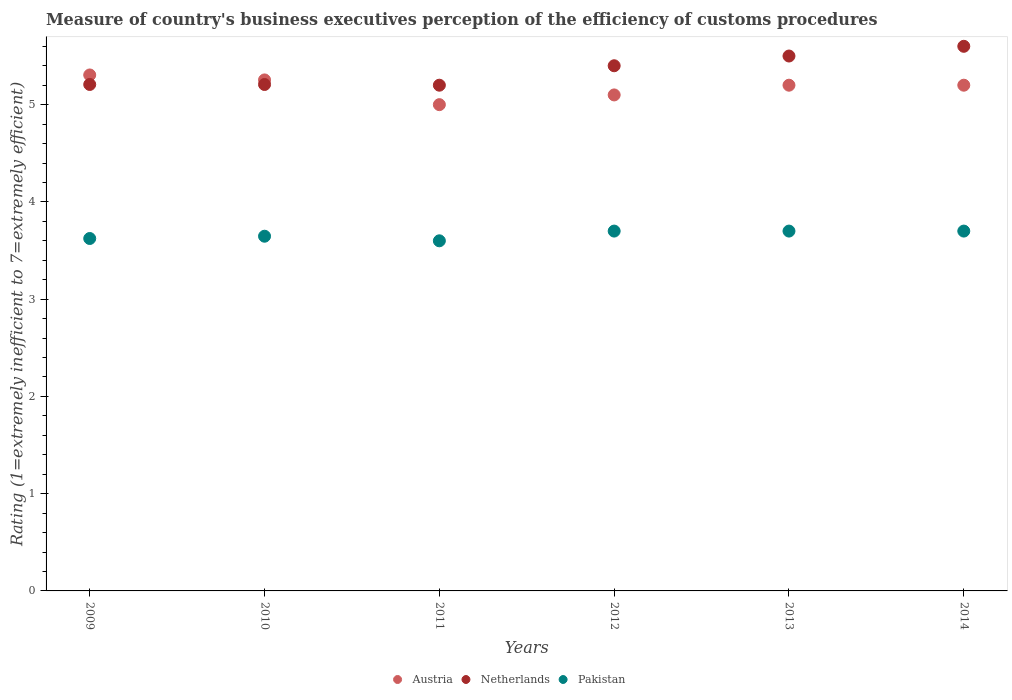What is the rating of the efficiency of customs procedure in Pakistan in 2014?
Ensure brevity in your answer.  3.7. Across all years, what is the maximum rating of the efficiency of customs procedure in Pakistan?
Offer a very short reply. 3.7. What is the total rating of the efficiency of customs procedure in Austria in the graph?
Your answer should be compact. 31.06. What is the difference between the rating of the efficiency of customs procedure in Netherlands in 2010 and that in 2014?
Your answer should be very brief. -0.39. What is the difference between the rating of the efficiency of customs procedure in Austria in 2011 and the rating of the efficiency of customs procedure in Pakistan in 2010?
Offer a very short reply. 1.35. What is the average rating of the efficiency of customs procedure in Netherlands per year?
Offer a terse response. 5.35. In how many years, is the rating of the efficiency of customs procedure in Pakistan greater than 0.8?
Provide a succinct answer. 6. What is the ratio of the rating of the efficiency of customs procedure in Austria in 2009 to that in 2012?
Provide a short and direct response. 1.04. Is the rating of the efficiency of customs procedure in Netherlands in 2010 less than that in 2012?
Offer a terse response. Yes. Is the difference between the rating of the efficiency of customs procedure in Pakistan in 2010 and 2012 greater than the difference between the rating of the efficiency of customs procedure in Austria in 2010 and 2012?
Offer a very short reply. No. What is the difference between the highest and the lowest rating of the efficiency of customs procedure in Netherlands?
Provide a short and direct response. 0.4. Is the sum of the rating of the efficiency of customs procedure in Netherlands in 2009 and 2014 greater than the maximum rating of the efficiency of customs procedure in Austria across all years?
Make the answer very short. Yes. Is it the case that in every year, the sum of the rating of the efficiency of customs procedure in Austria and rating of the efficiency of customs procedure in Pakistan  is greater than the rating of the efficiency of customs procedure in Netherlands?
Ensure brevity in your answer.  Yes. Does the rating of the efficiency of customs procedure in Pakistan monotonically increase over the years?
Give a very brief answer. No. Is the rating of the efficiency of customs procedure in Austria strictly greater than the rating of the efficiency of customs procedure in Pakistan over the years?
Offer a very short reply. Yes. How many dotlines are there?
Your answer should be compact. 3. How many years are there in the graph?
Ensure brevity in your answer.  6. How many legend labels are there?
Give a very brief answer. 3. What is the title of the graph?
Keep it short and to the point. Measure of country's business executives perception of the efficiency of customs procedures. What is the label or title of the X-axis?
Make the answer very short. Years. What is the label or title of the Y-axis?
Your answer should be very brief. Rating (1=extremely inefficient to 7=extremely efficient). What is the Rating (1=extremely inefficient to 7=extremely efficient) of Austria in 2009?
Keep it short and to the point. 5.31. What is the Rating (1=extremely inefficient to 7=extremely efficient) of Netherlands in 2009?
Offer a terse response. 5.21. What is the Rating (1=extremely inefficient to 7=extremely efficient) of Pakistan in 2009?
Your answer should be very brief. 3.62. What is the Rating (1=extremely inefficient to 7=extremely efficient) in Austria in 2010?
Your response must be concise. 5.25. What is the Rating (1=extremely inefficient to 7=extremely efficient) of Netherlands in 2010?
Keep it short and to the point. 5.21. What is the Rating (1=extremely inefficient to 7=extremely efficient) of Pakistan in 2010?
Your answer should be compact. 3.65. What is the Rating (1=extremely inefficient to 7=extremely efficient) of Netherlands in 2011?
Make the answer very short. 5.2. What is the Rating (1=extremely inefficient to 7=extremely efficient) in Pakistan in 2011?
Offer a terse response. 3.6. What is the Rating (1=extremely inefficient to 7=extremely efficient) in Netherlands in 2012?
Provide a short and direct response. 5.4. What is the Rating (1=extremely inefficient to 7=extremely efficient) in Pakistan in 2013?
Your response must be concise. 3.7. What is the Rating (1=extremely inefficient to 7=extremely efficient) in Austria in 2014?
Offer a terse response. 5.2. Across all years, what is the maximum Rating (1=extremely inefficient to 7=extremely efficient) in Austria?
Provide a succinct answer. 5.31. Across all years, what is the minimum Rating (1=extremely inefficient to 7=extremely efficient) of Pakistan?
Your answer should be very brief. 3.6. What is the total Rating (1=extremely inefficient to 7=extremely efficient) of Austria in the graph?
Offer a very short reply. 31.06. What is the total Rating (1=extremely inefficient to 7=extremely efficient) in Netherlands in the graph?
Offer a very short reply. 32.11. What is the total Rating (1=extremely inefficient to 7=extremely efficient) of Pakistan in the graph?
Provide a short and direct response. 21.97. What is the difference between the Rating (1=extremely inefficient to 7=extremely efficient) of Austria in 2009 and that in 2010?
Your answer should be compact. 0.05. What is the difference between the Rating (1=extremely inefficient to 7=extremely efficient) in Pakistan in 2009 and that in 2010?
Ensure brevity in your answer.  -0.02. What is the difference between the Rating (1=extremely inefficient to 7=extremely efficient) of Austria in 2009 and that in 2011?
Provide a succinct answer. 0.31. What is the difference between the Rating (1=extremely inefficient to 7=extremely efficient) in Netherlands in 2009 and that in 2011?
Provide a short and direct response. 0.01. What is the difference between the Rating (1=extremely inefficient to 7=extremely efficient) of Pakistan in 2009 and that in 2011?
Make the answer very short. 0.02. What is the difference between the Rating (1=extremely inefficient to 7=extremely efficient) in Austria in 2009 and that in 2012?
Offer a terse response. 0.21. What is the difference between the Rating (1=extremely inefficient to 7=extremely efficient) of Netherlands in 2009 and that in 2012?
Provide a short and direct response. -0.19. What is the difference between the Rating (1=extremely inefficient to 7=extremely efficient) of Pakistan in 2009 and that in 2012?
Provide a short and direct response. -0.08. What is the difference between the Rating (1=extremely inefficient to 7=extremely efficient) of Austria in 2009 and that in 2013?
Your answer should be compact. 0.11. What is the difference between the Rating (1=extremely inefficient to 7=extremely efficient) in Netherlands in 2009 and that in 2013?
Ensure brevity in your answer.  -0.29. What is the difference between the Rating (1=extremely inefficient to 7=extremely efficient) in Pakistan in 2009 and that in 2013?
Ensure brevity in your answer.  -0.08. What is the difference between the Rating (1=extremely inefficient to 7=extremely efficient) in Austria in 2009 and that in 2014?
Your answer should be very brief. 0.11. What is the difference between the Rating (1=extremely inefficient to 7=extremely efficient) of Netherlands in 2009 and that in 2014?
Offer a terse response. -0.39. What is the difference between the Rating (1=extremely inefficient to 7=extremely efficient) in Pakistan in 2009 and that in 2014?
Provide a succinct answer. -0.08. What is the difference between the Rating (1=extremely inefficient to 7=extremely efficient) in Austria in 2010 and that in 2011?
Your answer should be very brief. 0.25. What is the difference between the Rating (1=extremely inefficient to 7=extremely efficient) of Netherlands in 2010 and that in 2011?
Offer a very short reply. 0.01. What is the difference between the Rating (1=extremely inefficient to 7=extremely efficient) in Pakistan in 2010 and that in 2011?
Your answer should be compact. 0.05. What is the difference between the Rating (1=extremely inefficient to 7=extremely efficient) in Austria in 2010 and that in 2012?
Offer a very short reply. 0.15. What is the difference between the Rating (1=extremely inefficient to 7=extremely efficient) in Netherlands in 2010 and that in 2012?
Ensure brevity in your answer.  -0.19. What is the difference between the Rating (1=extremely inefficient to 7=extremely efficient) of Pakistan in 2010 and that in 2012?
Offer a terse response. -0.05. What is the difference between the Rating (1=extremely inefficient to 7=extremely efficient) of Austria in 2010 and that in 2013?
Your response must be concise. 0.05. What is the difference between the Rating (1=extremely inefficient to 7=extremely efficient) of Netherlands in 2010 and that in 2013?
Give a very brief answer. -0.29. What is the difference between the Rating (1=extremely inefficient to 7=extremely efficient) of Pakistan in 2010 and that in 2013?
Your answer should be compact. -0.05. What is the difference between the Rating (1=extremely inefficient to 7=extremely efficient) in Austria in 2010 and that in 2014?
Keep it short and to the point. 0.05. What is the difference between the Rating (1=extremely inefficient to 7=extremely efficient) in Netherlands in 2010 and that in 2014?
Ensure brevity in your answer.  -0.39. What is the difference between the Rating (1=extremely inefficient to 7=extremely efficient) of Pakistan in 2010 and that in 2014?
Keep it short and to the point. -0.05. What is the difference between the Rating (1=extremely inefficient to 7=extremely efficient) in Pakistan in 2011 and that in 2012?
Make the answer very short. -0.1. What is the difference between the Rating (1=extremely inefficient to 7=extremely efficient) of Austria in 2011 and that in 2013?
Make the answer very short. -0.2. What is the difference between the Rating (1=extremely inefficient to 7=extremely efficient) of Pakistan in 2011 and that in 2013?
Offer a terse response. -0.1. What is the difference between the Rating (1=extremely inefficient to 7=extremely efficient) in Pakistan in 2011 and that in 2014?
Your response must be concise. -0.1. What is the difference between the Rating (1=extremely inefficient to 7=extremely efficient) in Austria in 2012 and that in 2013?
Your response must be concise. -0.1. What is the difference between the Rating (1=extremely inefficient to 7=extremely efficient) of Netherlands in 2012 and that in 2013?
Provide a succinct answer. -0.1. What is the difference between the Rating (1=extremely inefficient to 7=extremely efficient) of Pakistan in 2012 and that in 2014?
Your answer should be compact. 0. What is the difference between the Rating (1=extremely inefficient to 7=extremely efficient) of Austria in 2013 and that in 2014?
Your response must be concise. 0. What is the difference between the Rating (1=extremely inefficient to 7=extremely efficient) in Pakistan in 2013 and that in 2014?
Keep it short and to the point. 0. What is the difference between the Rating (1=extremely inefficient to 7=extremely efficient) in Austria in 2009 and the Rating (1=extremely inefficient to 7=extremely efficient) in Netherlands in 2010?
Offer a very short reply. 0.1. What is the difference between the Rating (1=extremely inefficient to 7=extremely efficient) in Austria in 2009 and the Rating (1=extremely inefficient to 7=extremely efficient) in Pakistan in 2010?
Your response must be concise. 1.66. What is the difference between the Rating (1=extremely inefficient to 7=extremely efficient) in Netherlands in 2009 and the Rating (1=extremely inefficient to 7=extremely efficient) in Pakistan in 2010?
Give a very brief answer. 1.56. What is the difference between the Rating (1=extremely inefficient to 7=extremely efficient) of Austria in 2009 and the Rating (1=extremely inefficient to 7=extremely efficient) of Netherlands in 2011?
Ensure brevity in your answer.  0.11. What is the difference between the Rating (1=extremely inefficient to 7=extremely efficient) in Austria in 2009 and the Rating (1=extremely inefficient to 7=extremely efficient) in Pakistan in 2011?
Make the answer very short. 1.71. What is the difference between the Rating (1=extremely inefficient to 7=extremely efficient) in Netherlands in 2009 and the Rating (1=extremely inefficient to 7=extremely efficient) in Pakistan in 2011?
Provide a succinct answer. 1.61. What is the difference between the Rating (1=extremely inefficient to 7=extremely efficient) of Austria in 2009 and the Rating (1=extremely inefficient to 7=extremely efficient) of Netherlands in 2012?
Make the answer very short. -0.09. What is the difference between the Rating (1=extremely inefficient to 7=extremely efficient) of Austria in 2009 and the Rating (1=extremely inefficient to 7=extremely efficient) of Pakistan in 2012?
Your answer should be compact. 1.61. What is the difference between the Rating (1=extremely inefficient to 7=extremely efficient) of Netherlands in 2009 and the Rating (1=extremely inefficient to 7=extremely efficient) of Pakistan in 2012?
Your answer should be very brief. 1.51. What is the difference between the Rating (1=extremely inefficient to 7=extremely efficient) in Austria in 2009 and the Rating (1=extremely inefficient to 7=extremely efficient) in Netherlands in 2013?
Your answer should be compact. -0.19. What is the difference between the Rating (1=extremely inefficient to 7=extremely efficient) of Austria in 2009 and the Rating (1=extremely inefficient to 7=extremely efficient) of Pakistan in 2013?
Provide a short and direct response. 1.61. What is the difference between the Rating (1=extremely inefficient to 7=extremely efficient) of Netherlands in 2009 and the Rating (1=extremely inefficient to 7=extremely efficient) of Pakistan in 2013?
Give a very brief answer. 1.51. What is the difference between the Rating (1=extremely inefficient to 7=extremely efficient) in Austria in 2009 and the Rating (1=extremely inefficient to 7=extremely efficient) in Netherlands in 2014?
Provide a succinct answer. -0.29. What is the difference between the Rating (1=extremely inefficient to 7=extremely efficient) of Austria in 2009 and the Rating (1=extremely inefficient to 7=extremely efficient) of Pakistan in 2014?
Provide a succinct answer. 1.61. What is the difference between the Rating (1=extremely inefficient to 7=extremely efficient) of Netherlands in 2009 and the Rating (1=extremely inefficient to 7=extremely efficient) of Pakistan in 2014?
Make the answer very short. 1.51. What is the difference between the Rating (1=extremely inefficient to 7=extremely efficient) in Austria in 2010 and the Rating (1=extremely inefficient to 7=extremely efficient) in Netherlands in 2011?
Keep it short and to the point. 0.05. What is the difference between the Rating (1=extremely inefficient to 7=extremely efficient) in Austria in 2010 and the Rating (1=extremely inefficient to 7=extremely efficient) in Pakistan in 2011?
Offer a very short reply. 1.65. What is the difference between the Rating (1=extremely inefficient to 7=extremely efficient) in Netherlands in 2010 and the Rating (1=extremely inefficient to 7=extremely efficient) in Pakistan in 2011?
Give a very brief answer. 1.61. What is the difference between the Rating (1=extremely inefficient to 7=extremely efficient) of Austria in 2010 and the Rating (1=extremely inefficient to 7=extremely efficient) of Netherlands in 2012?
Your answer should be compact. -0.15. What is the difference between the Rating (1=extremely inefficient to 7=extremely efficient) of Austria in 2010 and the Rating (1=extremely inefficient to 7=extremely efficient) of Pakistan in 2012?
Offer a very short reply. 1.55. What is the difference between the Rating (1=extremely inefficient to 7=extremely efficient) in Netherlands in 2010 and the Rating (1=extremely inefficient to 7=extremely efficient) in Pakistan in 2012?
Your response must be concise. 1.51. What is the difference between the Rating (1=extremely inefficient to 7=extremely efficient) in Austria in 2010 and the Rating (1=extremely inefficient to 7=extremely efficient) in Netherlands in 2013?
Provide a short and direct response. -0.25. What is the difference between the Rating (1=extremely inefficient to 7=extremely efficient) of Austria in 2010 and the Rating (1=extremely inefficient to 7=extremely efficient) of Pakistan in 2013?
Provide a succinct answer. 1.55. What is the difference between the Rating (1=extremely inefficient to 7=extremely efficient) in Netherlands in 2010 and the Rating (1=extremely inefficient to 7=extremely efficient) in Pakistan in 2013?
Give a very brief answer. 1.51. What is the difference between the Rating (1=extremely inefficient to 7=extremely efficient) of Austria in 2010 and the Rating (1=extremely inefficient to 7=extremely efficient) of Netherlands in 2014?
Offer a very short reply. -0.35. What is the difference between the Rating (1=extremely inefficient to 7=extremely efficient) in Austria in 2010 and the Rating (1=extremely inefficient to 7=extremely efficient) in Pakistan in 2014?
Offer a very short reply. 1.55. What is the difference between the Rating (1=extremely inefficient to 7=extremely efficient) of Netherlands in 2010 and the Rating (1=extremely inefficient to 7=extremely efficient) of Pakistan in 2014?
Make the answer very short. 1.51. What is the difference between the Rating (1=extremely inefficient to 7=extremely efficient) of Austria in 2011 and the Rating (1=extremely inefficient to 7=extremely efficient) of Pakistan in 2012?
Your answer should be very brief. 1.3. What is the difference between the Rating (1=extremely inefficient to 7=extremely efficient) in Netherlands in 2011 and the Rating (1=extremely inefficient to 7=extremely efficient) in Pakistan in 2012?
Your answer should be very brief. 1.5. What is the difference between the Rating (1=extremely inefficient to 7=extremely efficient) of Austria in 2011 and the Rating (1=extremely inefficient to 7=extremely efficient) of Netherlands in 2013?
Make the answer very short. -0.5. What is the difference between the Rating (1=extremely inefficient to 7=extremely efficient) of Austria in 2011 and the Rating (1=extremely inefficient to 7=extremely efficient) of Pakistan in 2014?
Offer a terse response. 1.3. What is the difference between the Rating (1=extremely inefficient to 7=extremely efficient) of Netherlands in 2011 and the Rating (1=extremely inefficient to 7=extremely efficient) of Pakistan in 2014?
Give a very brief answer. 1.5. What is the difference between the Rating (1=extremely inefficient to 7=extremely efficient) of Austria in 2012 and the Rating (1=extremely inefficient to 7=extremely efficient) of Netherlands in 2013?
Ensure brevity in your answer.  -0.4. What is the difference between the Rating (1=extremely inefficient to 7=extremely efficient) of Austria in 2012 and the Rating (1=extremely inefficient to 7=extremely efficient) of Pakistan in 2013?
Offer a very short reply. 1.4. What is the difference between the Rating (1=extremely inefficient to 7=extremely efficient) in Austria in 2012 and the Rating (1=extremely inefficient to 7=extremely efficient) in Netherlands in 2014?
Offer a very short reply. -0.5. What is the difference between the Rating (1=extremely inefficient to 7=extremely efficient) in Austria in 2012 and the Rating (1=extremely inefficient to 7=extremely efficient) in Pakistan in 2014?
Keep it short and to the point. 1.4. What is the average Rating (1=extremely inefficient to 7=extremely efficient) in Austria per year?
Make the answer very short. 5.18. What is the average Rating (1=extremely inefficient to 7=extremely efficient) in Netherlands per year?
Offer a terse response. 5.35. What is the average Rating (1=extremely inefficient to 7=extremely efficient) of Pakistan per year?
Give a very brief answer. 3.66. In the year 2009, what is the difference between the Rating (1=extremely inefficient to 7=extremely efficient) of Austria and Rating (1=extremely inefficient to 7=extremely efficient) of Netherlands?
Offer a very short reply. 0.1. In the year 2009, what is the difference between the Rating (1=extremely inefficient to 7=extremely efficient) in Austria and Rating (1=extremely inefficient to 7=extremely efficient) in Pakistan?
Offer a very short reply. 1.68. In the year 2009, what is the difference between the Rating (1=extremely inefficient to 7=extremely efficient) in Netherlands and Rating (1=extremely inefficient to 7=extremely efficient) in Pakistan?
Make the answer very short. 1.58. In the year 2010, what is the difference between the Rating (1=extremely inefficient to 7=extremely efficient) in Austria and Rating (1=extremely inefficient to 7=extremely efficient) in Netherlands?
Make the answer very short. 0.05. In the year 2010, what is the difference between the Rating (1=extremely inefficient to 7=extremely efficient) of Austria and Rating (1=extremely inefficient to 7=extremely efficient) of Pakistan?
Keep it short and to the point. 1.61. In the year 2010, what is the difference between the Rating (1=extremely inefficient to 7=extremely efficient) of Netherlands and Rating (1=extremely inefficient to 7=extremely efficient) of Pakistan?
Make the answer very short. 1.56. In the year 2011, what is the difference between the Rating (1=extremely inefficient to 7=extremely efficient) in Austria and Rating (1=extremely inefficient to 7=extremely efficient) in Netherlands?
Make the answer very short. -0.2. In the year 2011, what is the difference between the Rating (1=extremely inefficient to 7=extremely efficient) in Austria and Rating (1=extremely inefficient to 7=extremely efficient) in Pakistan?
Offer a very short reply. 1.4. In the year 2011, what is the difference between the Rating (1=extremely inefficient to 7=extremely efficient) in Netherlands and Rating (1=extremely inefficient to 7=extremely efficient) in Pakistan?
Offer a terse response. 1.6. In the year 2012, what is the difference between the Rating (1=extremely inefficient to 7=extremely efficient) in Austria and Rating (1=extremely inefficient to 7=extremely efficient) in Netherlands?
Your answer should be very brief. -0.3. In the year 2012, what is the difference between the Rating (1=extremely inefficient to 7=extremely efficient) in Netherlands and Rating (1=extremely inefficient to 7=extremely efficient) in Pakistan?
Your answer should be very brief. 1.7. In the year 2013, what is the difference between the Rating (1=extremely inefficient to 7=extremely efficient) in Austria and Rating (1=extremely inefficient to 7=extremely efficient) in Netherlands?
Give a very brief answer. -0.3. In the year 2014, what is the difference between the Rating (1=extremely inefficient to 7=extremely efficient) in Austria and Rating (1=extremely inefficient to 7=extremely efficient) in Netherlands?
Provide a short and direct response. -0.4. In the year 2014, what is the difference between the Rating (1=extremely inefficient to 7=extremely efficient) of Austria and Rating (1=extremely inefficient to 7=extremely efficient) of Pakistan?
Your response must be concise. 1.5. In the year 2014, what is the difference between the Rating (1=extremely inefficient to 7=extremely efficient) in Netherlands and Rating (1=extremely inefficient to 7=extremely efficient) in Pakistan?
Offer a terse response. 1.9. What is the ratio of the Rating (1=extremely inefficient to 7=extremely efficient) of Austria in 2009 to that in 2010?
Your answer should be compact. 1.01. What is the ratio of the Rating (1=extremely inefficient to 7=extremely efficient) in Netherlands in 2009 to that in 2010?
Your response must be concise. 1. What is the ratio of the Rating (1=extremely inefficient to 7=extremely efficient) in Austria in 2009 to that in 2011?
Make the answer very short. 1.06. What is the ratio of the Rating (1=extremely inefficient to 7=extremely efficient) of Pakistan in 2009 to that in 2011?
Ensure brevity in your answer.  1.01. What is the ratio of the Rating (1=extremely inefficient to 7=extremely efficient) in Austria in 2009 to that in 2012?
Offer a very short reply. 1.04. What is the ratio of the Rating (1=extremely inefficient to 7=extremely efficient) of Netherlands in 2009 to that in 2012?
Make the answer very short. 0.96. What is the ratio of the Rating (1=extremely inefficient to 7=extremely efficient) in Pakistan in 2009 to that in 2012?
Keep it short and to the point. 0.98. What is the ratio of the Rating (1=extremely inefficient to 7=extremely efficient) of Austria in 2009 to that in 2013?
Provide a short and direct response. 1.02. What is the ratio of the Rating (1=extremely inefficient to 7=extremely efficient) of Netherlands in 2009 to that in 2013?
Your response must be concise. 0.95. What is the ratio of the Rating (1=extremely inefficient to 7=extremely efficient) of Pakistan in 2009 to that in 2013?
Keep it short and to the point. 0.98. What is the ratio of the Rating (1=extremely inefficient to 7=extremely efficient) in Austria in 2009 to that in 2014?
Offer a very short reply. 1.02. What is the ratio of the Rating (1=extremely inefficient to 7=extremely efficient) of Netherlands in 2009 to that in 2014?
Give a very brief answer. 0.93. What is the ratio of the Rating (1=extremely inefficient to 7=extremely efficient) of Pakistan in 2009 to that in 2014?
Give a very brief answer. 0.98. What is the ratio of the Rating (1=extremely inefficient to 7=extremely efficient) of Austria in 2010 to that in 2011?
Your response must be concise. 1.05. What is the ratio of the Rating (1=extremely inefficient to 7=extremely efficient) in Pakistan in 2010 to that in 2011?
Provide a succinct answer. 1.01. What is the ratio of the Rating (1=extremely inefficient to 7=extremely efficient) of Austria in 2010 to that in 2012?
Keep it short and to the point. 1.03. What is the ratio of the Rating (1=extremely inefficient to 7=extremely efficient) of Pakistan in 2010 to that in 2012?
Your answer should be compact. 0.99. What is the ratio of the Rating (1=extremely inefficient to 7=extremely efficient) in Austria in 2010 to that in 2013?
Give a very brief answer. 1.01. What is the ratio of the Rating (1=extremely inefficient to 7=extremely efficient) of Netherlands in 2010 to that in 2013?
Give a very brief answer. 0.95. What is the ratio of the Rating (1=extremely inefficient to 7=extremely efficient) of Pakistan in 2010 to that in 2013?
Your answer should be compact. 0.99. What is the ratio of the Rating (1=extremely inefficient to 7=extremely efficient) in Austria in 2010 to that in 2014?
Offer a very short reply. 1.01. What is the ratio of the Rating (1=extremely inefficient to 7=extremely efficient) in Netherlands in 2010 to that in 2014?
Your response must be concise. 0.93. What is the ratio of the Rating (1=extremely inefficient to 7=extremely efficient) of Pakistan in 2010 to that in 2014?
Make the answer very short. 0.99. What is the ratio of the Rating (1=extremely inefficient to 7=extremely efficient) in Austria in 2011 to that in 2012?
Your answer should be compact. 0.98. What is the ratio of the Rating (1=extremely inefficient to 7=extremely efficient) in Netherlands in 2011 to that in 2012?
Make the answer very short. 0.96. What is the ratio of the Rating (1=extremely inefficient to 7=extremely efficient) of Austria in 2011 to that in 2013?
Give a very brief answer. 0.96. What is the ratio of the Rating (1=extremely inefficient to 7=extremely efficient) of Netherlands in 2011 to that in 2013?
Your answer should be compact. 0.95. What is the ratio of the Rating (1=extremely inefficient to 7=extremely efficient) of Pakistan in 2011 to that in 2013?
Offer a terse response. 0.97. What is the ratio of the Rating (1=extremely inefficient to 7=extremely efficient) of Austria in 2011 to that in 2014?
Your answer should be compact. 0.96. What is the ratio of the Rating (1=extremely inefficient to 7=extremely efficient) of Austria in 2012 to that in 2013?
Make the answer very short. 0.98. What is the ratio of the Rating (1=extremely inefficient to 7=extremely efficient) in Netherlands in 2012 to that in 2013?
Provide a succinct answer. 0.98. What is the ratio of the Rating (1=extremely inefficient to 7=extremely efficient) in Pakistan in 2012 to that in 2013?
Keep it short and to the point. 1. What is the ratio of the Rating (1=extremely inefficient to 7=extremely efficient) of Austria in 2012 to that in 2014?
Offer a very short reply. 0.98. What is the ratio of the Rating (1=extremely inefficient to 7=extremely efficient) in Pakistan in 2012 to that in 2014?
Make the answer very short. 1. What is the ratio of the Rating (1=extremely inefficient to 7=extremely efficient) in Netherlands in 2013 to that in 2014?
Give a very brief answer. 0.98. What is the difference between the highest and the second highest Rating (1=extremely inefficient to 7=extremely efficient) of Austria?
Ensure brevity in your answer.  0.05. What is the difference between the highest and the lowest Rating (1=extremely inefficient to 7=extremely efficient) in Austria?
Make the answer very short. 0.31. What is the difference between the highest and the lowest Rating (1=extremely inefficient to 7=extremely efficient) in Pakistan?
Provide a short and direct response. 0.1. 